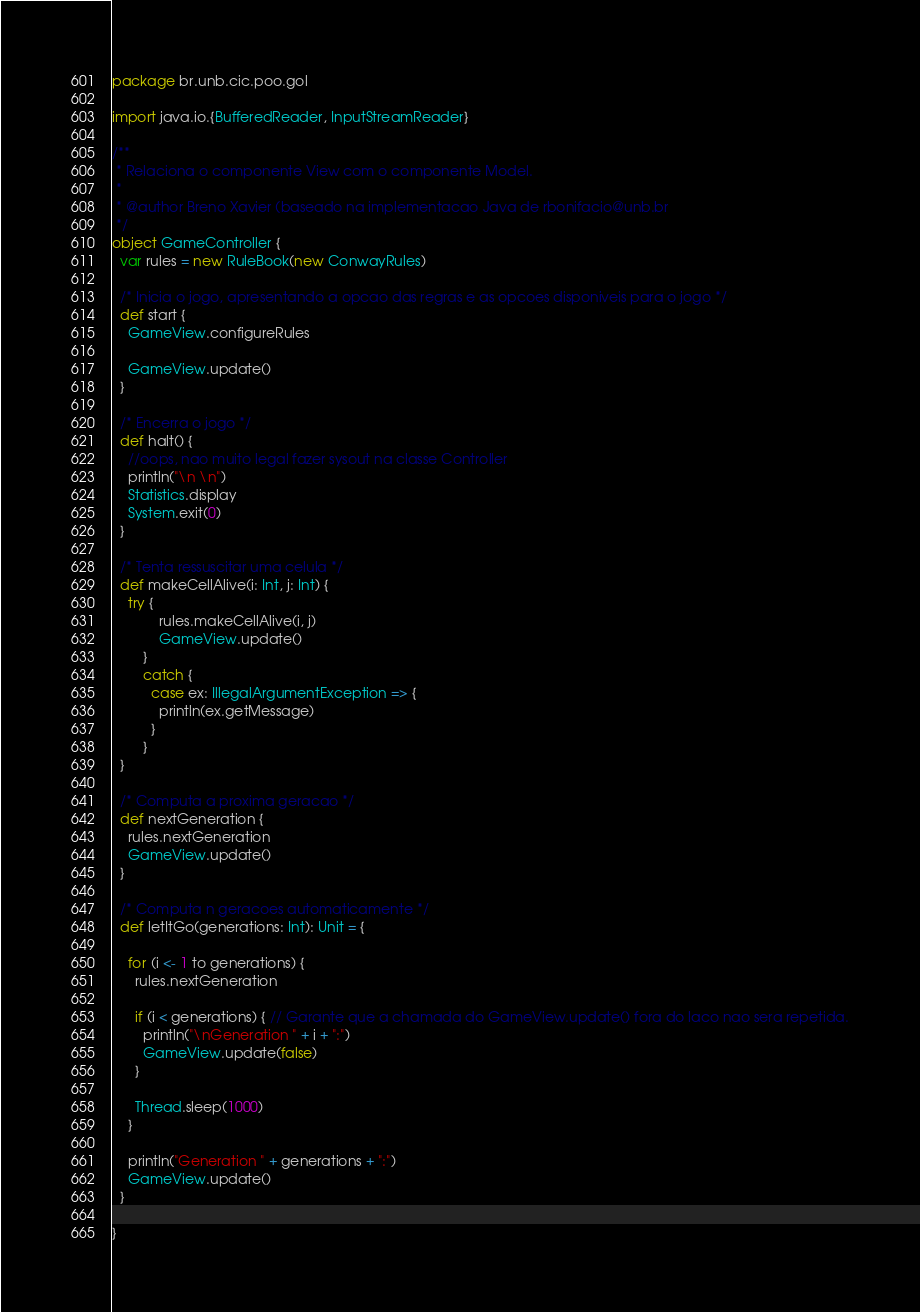<code> <loc_0><loc_0><loc_500><loc_500><_Scala_>package br.unb.cic.poo.gol

import java.io.{BufferedReader, InputStreamReader}

/**
 * Relaciona o componente View com o componente Model. 
 * 
 * @author Breno Xavier (baseado na implementacao Java de rbonifacio@unb.br
 */
object GameController {
  var rules = new RuleBook(new ConwayRules)

  /* Inicia o jogo, apresentando a opcao das regras e as opcoes disponiveis para o jogo */
  def start {
    GameView.configureRules

    GameView.update()
  }

  /* Encerra o jogo */
  def halt() {
    //oops, nao muito legal fazer sysout na classe Controller
    println("\n \n")
    Statistics.display
    System.exit(0)
  }

  /* Tenta ressuscitar uma celula */
  def makeCellAlive(i: Int, j: Int) {
    try {
			rules.makeCellAlive(i, j)
			GameView.update()
		}
		catch {
		  case ex: IllegalArgumentException => {
		    println(ex.getMessage)
		  }
		}
  }

  /* Computa a proxima geracao */
  def nextGeneration {
    rules.nextGeneration
    GameView.update()
  }

  /* Computa n geracoes automaticamente */
  def letItGo(generations: Int): Unit = {

    for (i <- 1 to generations) {
      rules.nextGeneration

      if (i < generations) { // Garante que a chamada do GameView.update() fora do laco nao sera repetida.
        println("\nGeneration " + i + ":")
        GameView.update(false)
      }

      Thread.sleep(1000)
    }

    println("Generation " + generations + ":")
    GameView.update()
  }
  
}</code> 